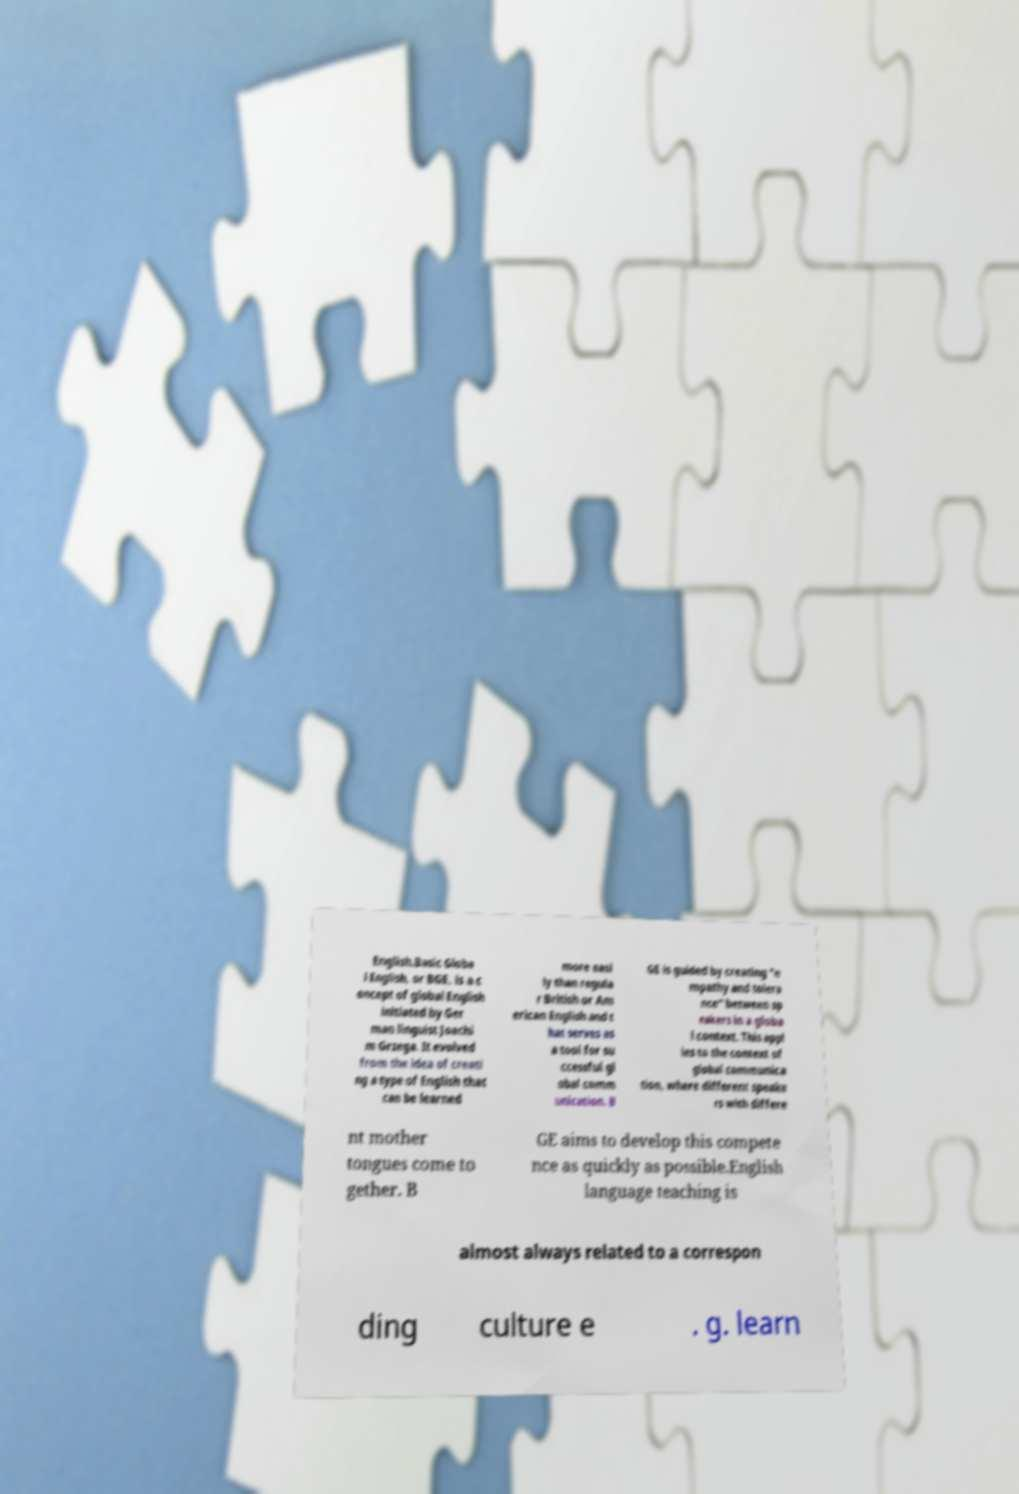Can you accurately transcribe the text from the provided image for me? English.Basic Globa l English, or BGE, is a c oncept of global English initiated by Ger man linguist Joachi m Grzega. It evolved from the idea of creati ng a type of English that can be learned more easi ly than regula r British or Am erican English and t hat serves as a tool for su ccessful gl obal comm unication. B GE is guided by creating "e mpathy and tolera nce" between sp eakers in a globa l context. This appl ies to the context of global communica tion, where different speake rs with differe nt mother tongues come to gether. B GE aims to develop this compete nce as quickly as possible.English language teaching is almost always related to a correspon ding culture e . g. learn 